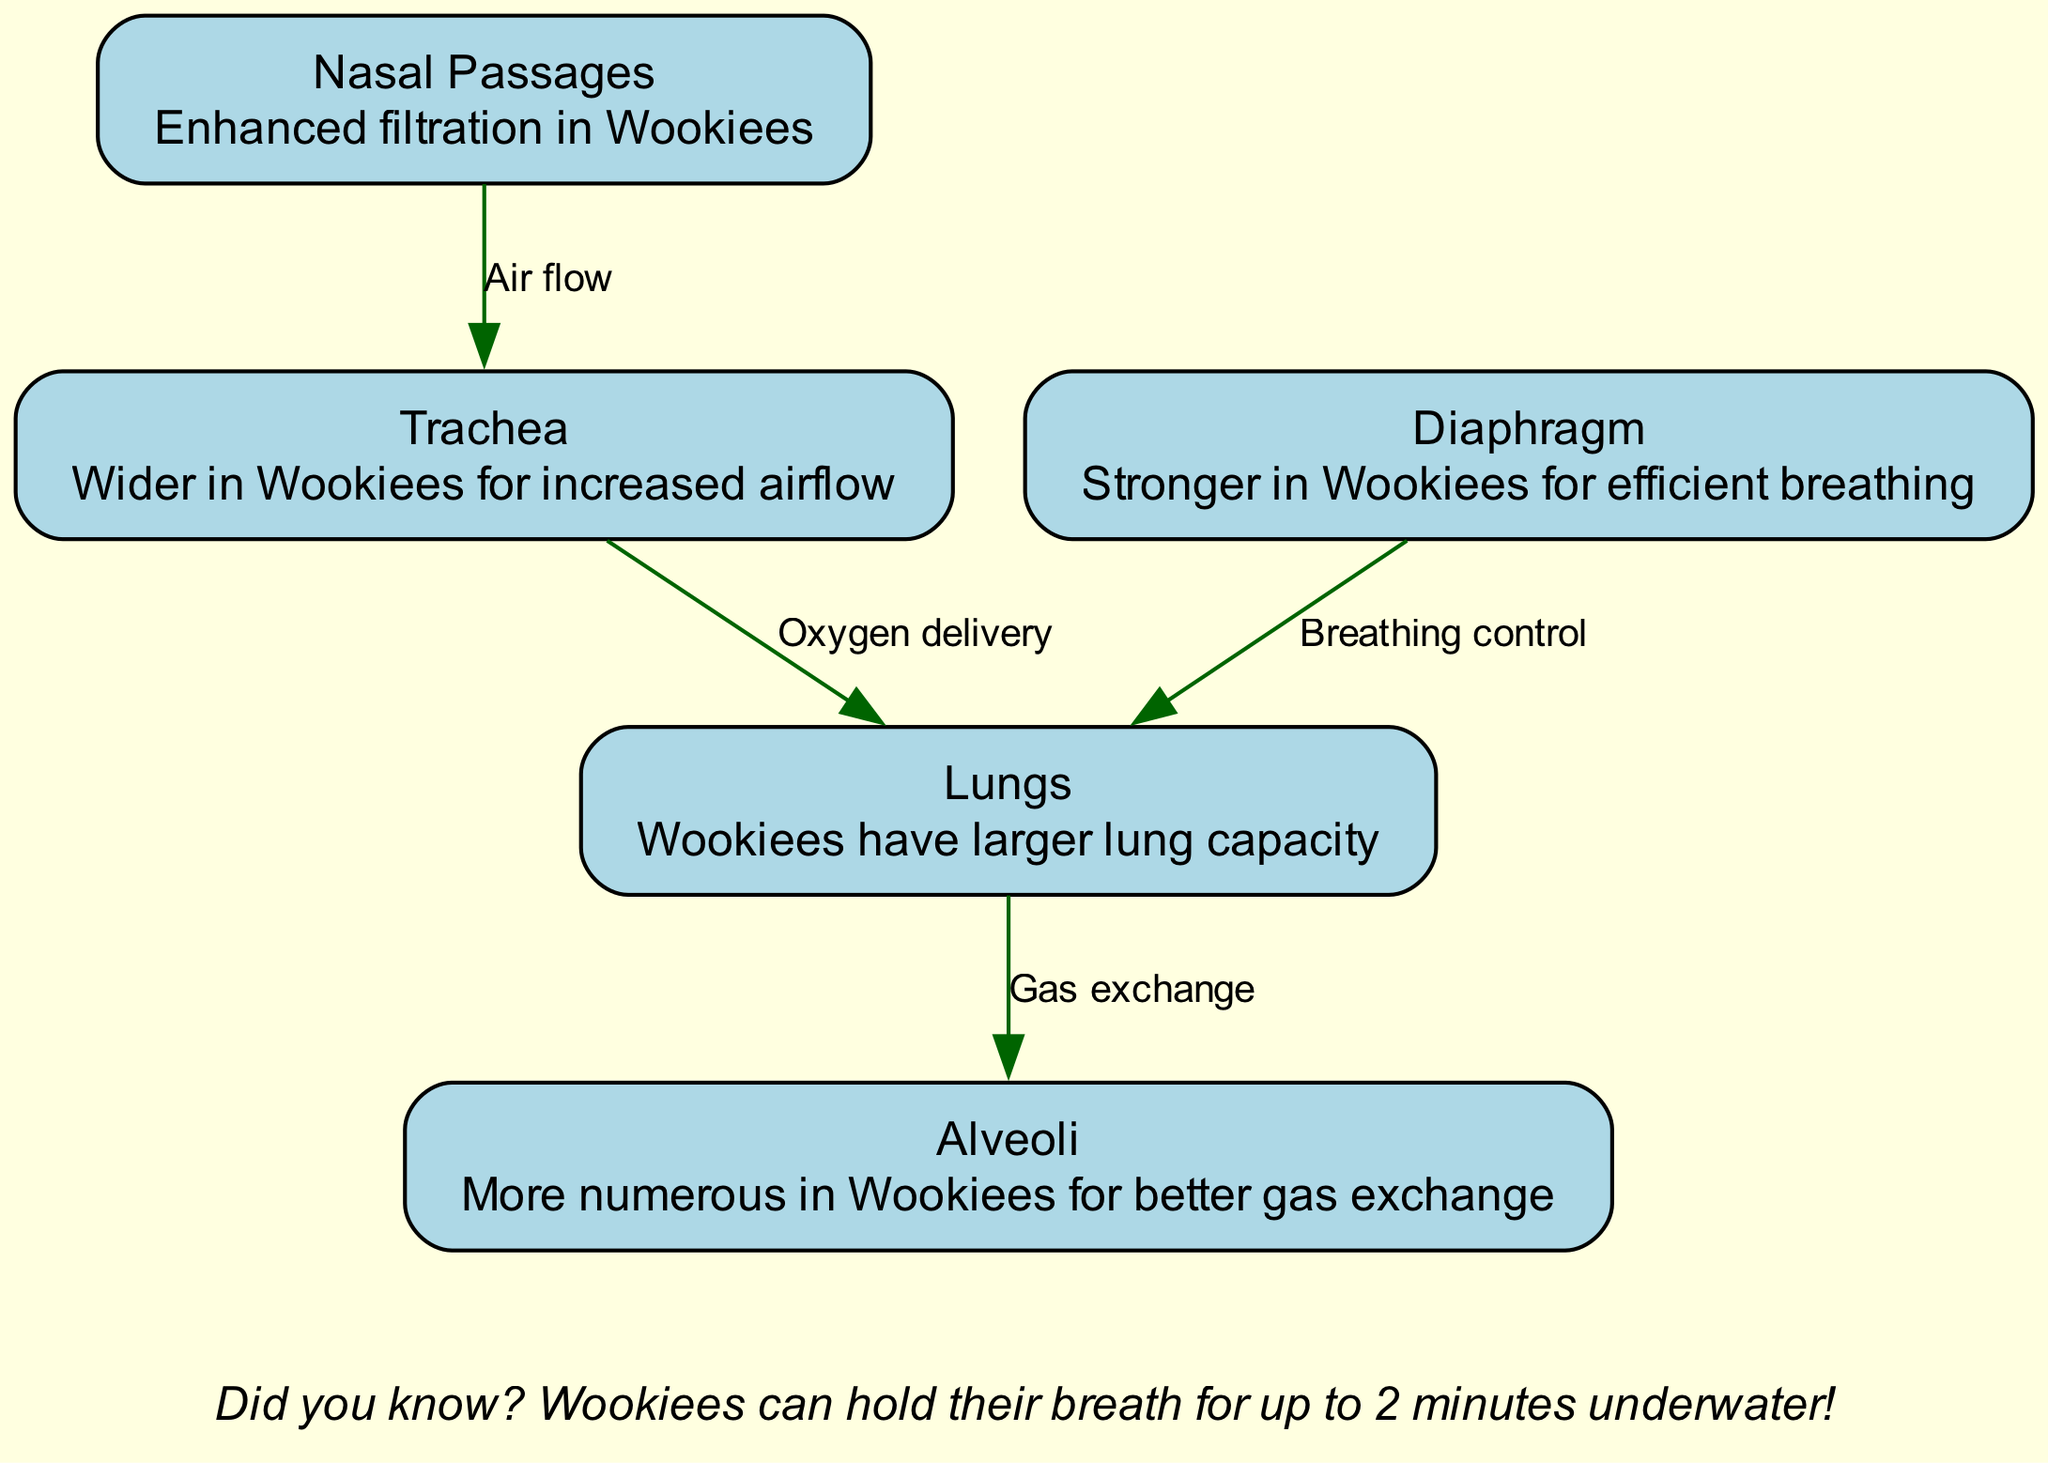What is the primary respiratory structure that Wookiees have larger than humans? The diagram specifies that Wookiees have "larger lung capacity" compared to humans, indicating that the lungs are the primary structure with a notable difference.
Answer: Lungs How many nodes are present in the diagram? The diagram clearly lists 5 different nodes (lungs, trachea, diaphragm, nasal passages, alveoli). Thus, counting these gives a total of 5 nodes.
Answer: 5 What is the relationship between the trachea and the lungs? According to the diagram, the trachea is linked to the lungs with the label "Oxygen delivery," indicating that the trachea plays a role in transferring oxygen to the lungs.
Answer: Oxygen delivery Which respiratory system part has enhanced filtration in Wookiees? The diagram states that Wookiees have "Enhanced filtration" in their nasal passages, indicating this specific part has a notable difference regarding filtration capacity.
Answer: Nasal Passages How many edges are there in the diagram? The diagram contains 4 edges, detailing the flow of air and oxygen between the nodes: nasal passages to trachea, trachea to lungs, lungs to alveoli, and diaphragm to lungs.
Answer: 4 What characteristic of Wookiee alveoli is notable in the diagram? The description for alveoli explains that they are "More numerous in Wookiees for better gas exchange." This highlights the key difference in this structure between Wookiees and humans.
Answer: More numerous Which respiratory part is described as having stronger muscles in Wookiees? The diagram mentions that the diaphragm is "Stronger in Wookiees for efficient breathing," indicating that this part has a notable muscular advantage.
Answer: Diaphragm What is the purpose of the edges labeled in the diagram? Each edge in the diagram describes a relationship between respiratory structures, such as air flow and oxygen delivery, representing how air moves through the respiratory system.
Answer: Describes airflow relationships 